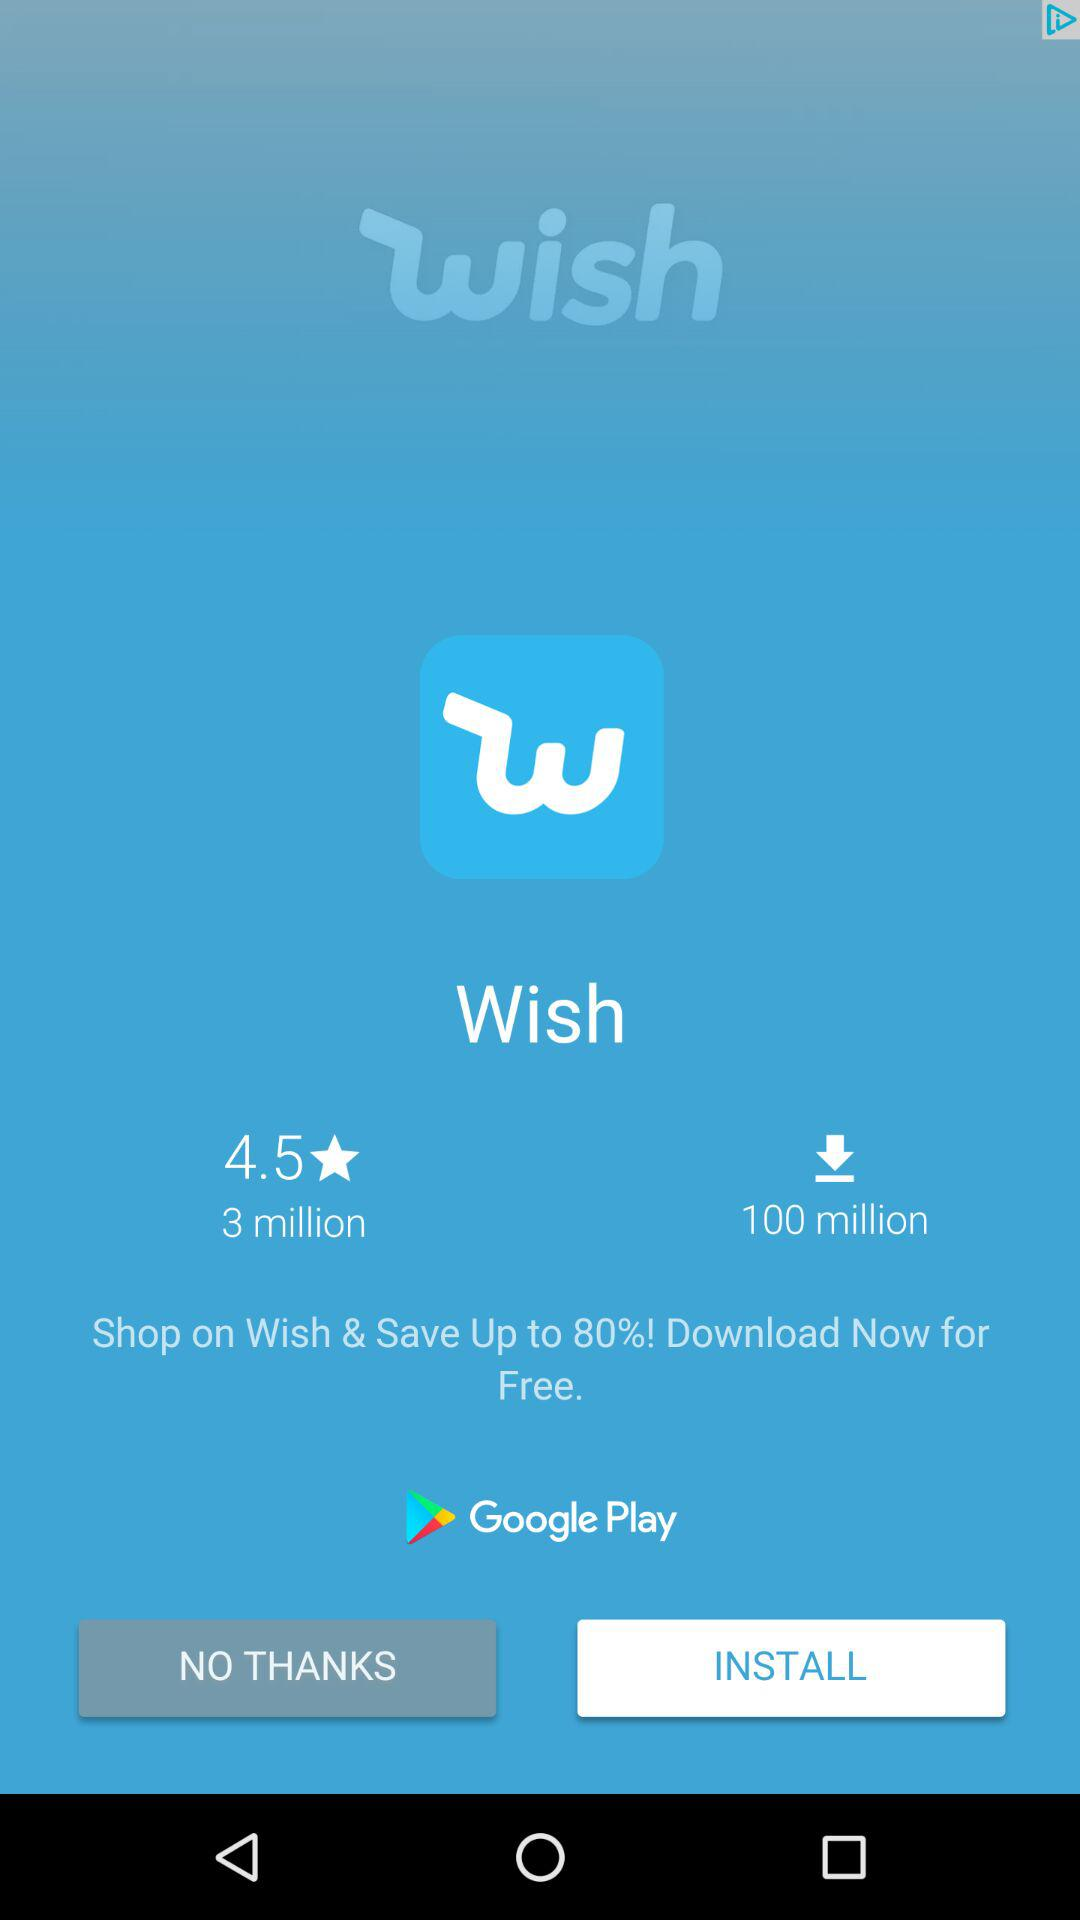How many more downloads does the app have than reviews?
Answer the question using a single word or phrase. 97 million 